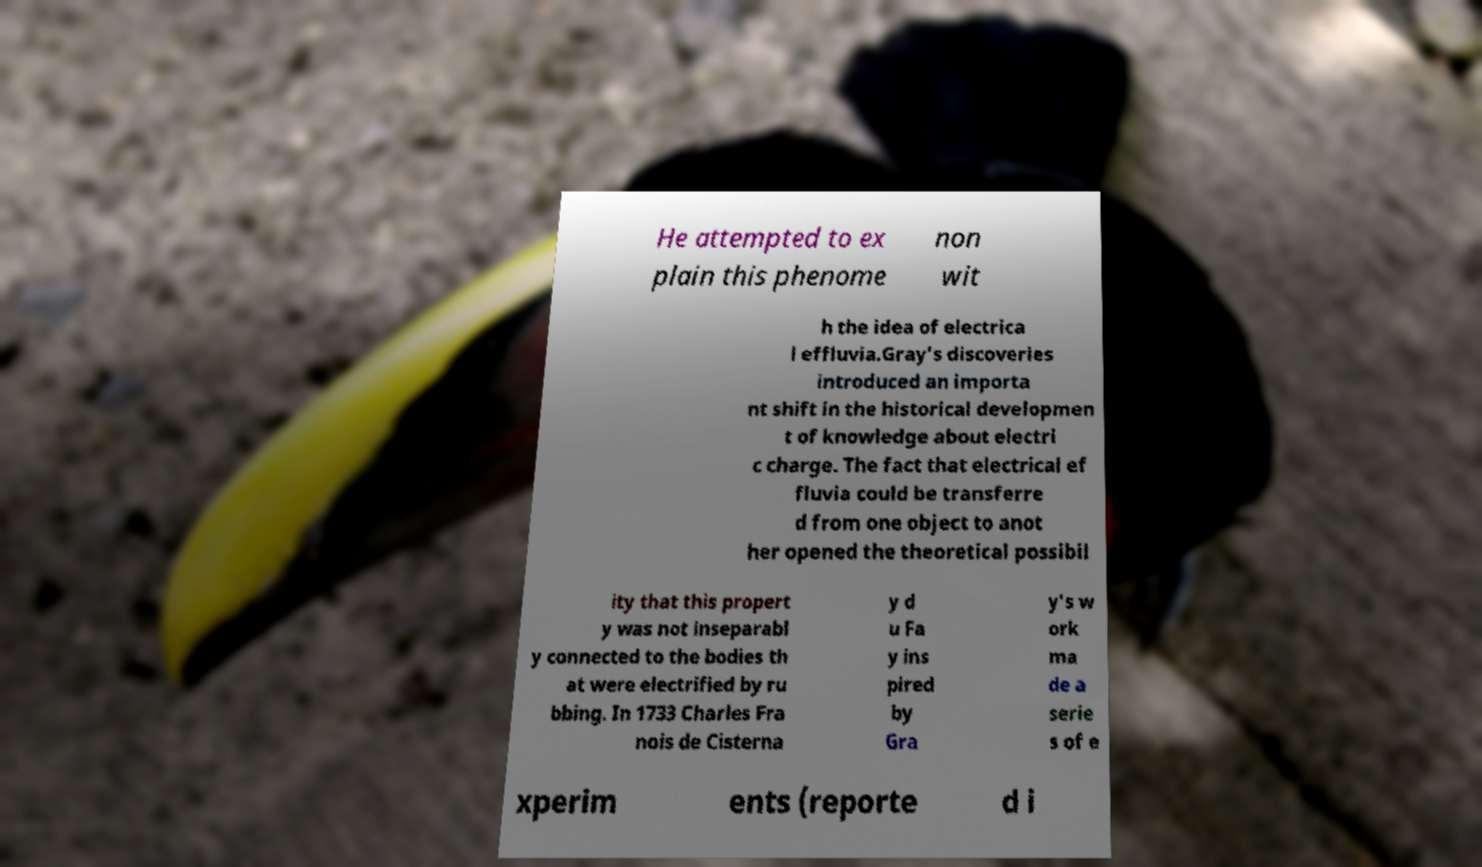Please identify and transcribe the text found in this image. He attempted to ex plain this phenome non wit h the idea of electrica l effluvia.Gray's discoveries introduced an importa nt shift in the historical developmen t of knowledge about electri c charge. The fact that electrical ef fluvia could be transferre d from one object to anot her opened the theoretical possibil ity that this propert y was not inseparabl y connected to the bodies th at were electrified by ru bbing. In 1733 Charles Fra nois de Cisterna y d u Fa y ins pired by Gra y's w ork ma de a serie s of e xperim ents (reporte d i 